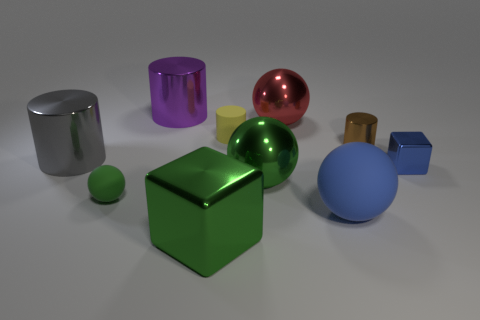Subtract all large spheres. How many spheres are left? 1 Subtract all red balls. How many balls are left? 3 Subtract all spheres. How many objects are left? 6 Subtract all blue balls. How many blue cylinders are left? 0 Subtract all gray cylinders. Subtract all tiny gray metallic objects. How many objects are left? 9 Add 5 large blue matte objects. How many large blue matte objects are left? 6 Add 4 large metallic blocks. How many large metallic blocks exist? 5 Subtract 1 gray cylinders. How many objects are left? 9 Subtract 2 cylinders. How many cylinders are left? 2 Subtract all green blocks. Subtract all yellow cylinders. How many blocks are left? 1 